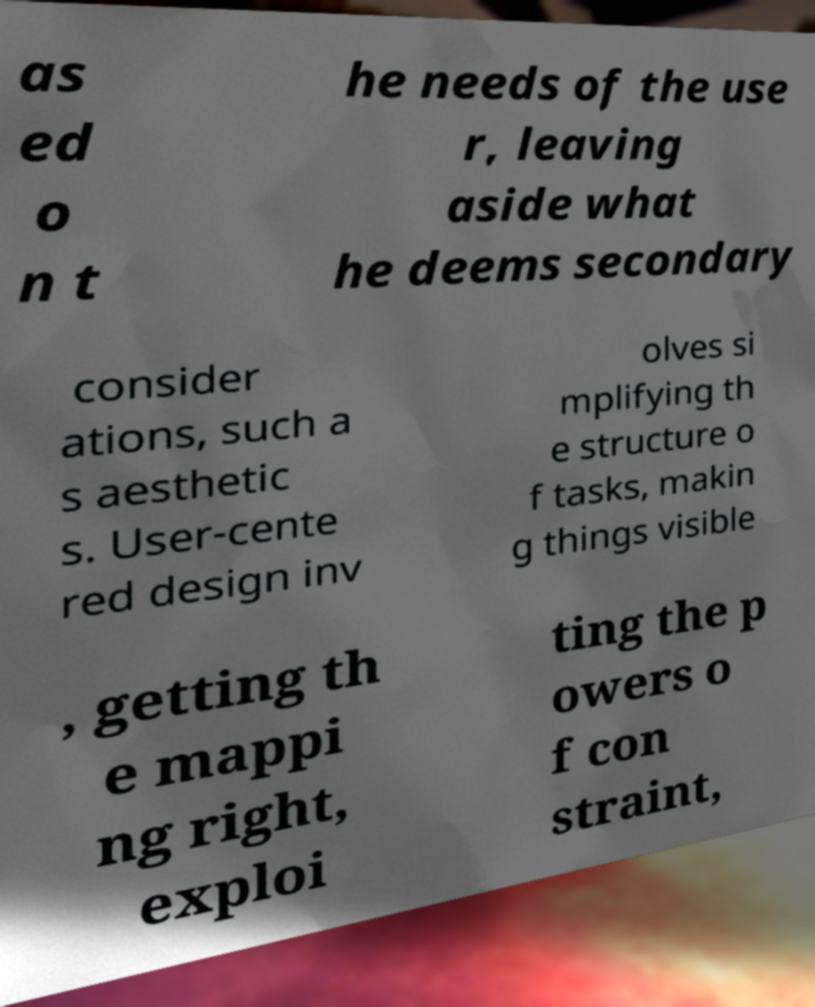For documentation purposes, I need the text within this image transcribed. Could you provide that? as ed o n t he needs of the use r, leaving aside what he deems secondary consider ations, such a s aesthetic s. User-cente red design inv olves si mplifying th e structure o f tasks, makin g things visible , getting th e mappi ng right, exploi ting the p owers o f con straint, 